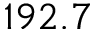Convert formula to latex. <formula><loc_0><loc_0><loc_500><loc_500>1 9 2 . 7</formula> 